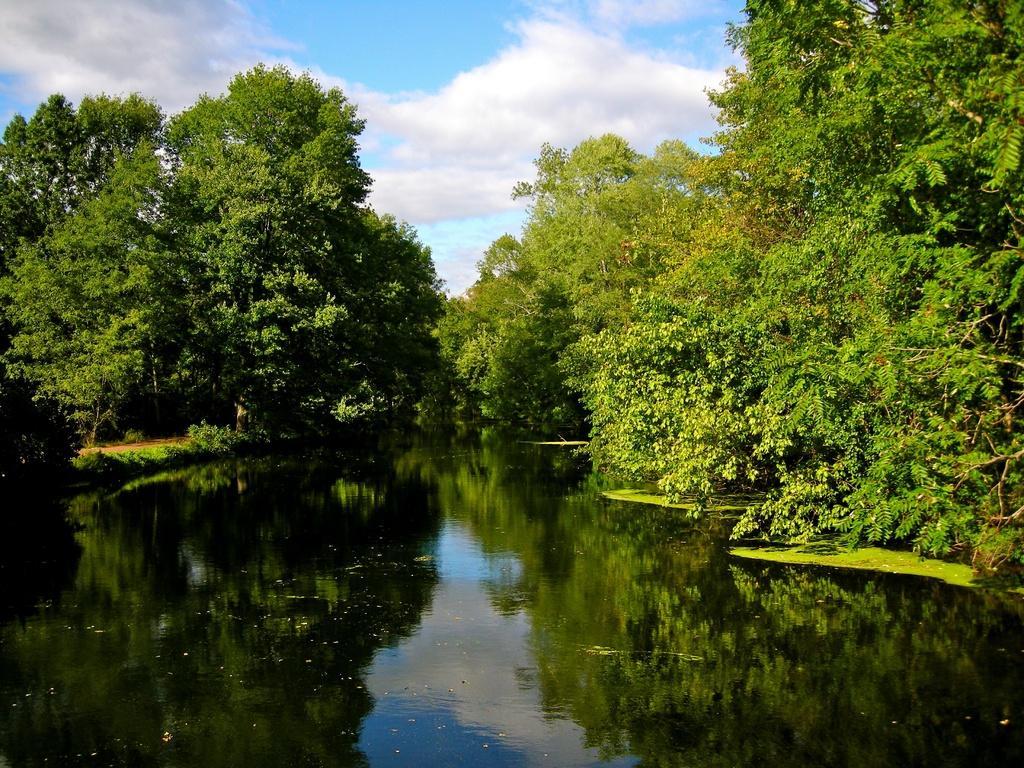How would you summarize this image in a sentence or two? In this picture there is water at the bottom side of the image and there is greenery in the center of the image. 